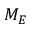Convert formula to latex. <formula><loc_0><loc_0><loc_500><loc_500>M _ { E }</formula> 